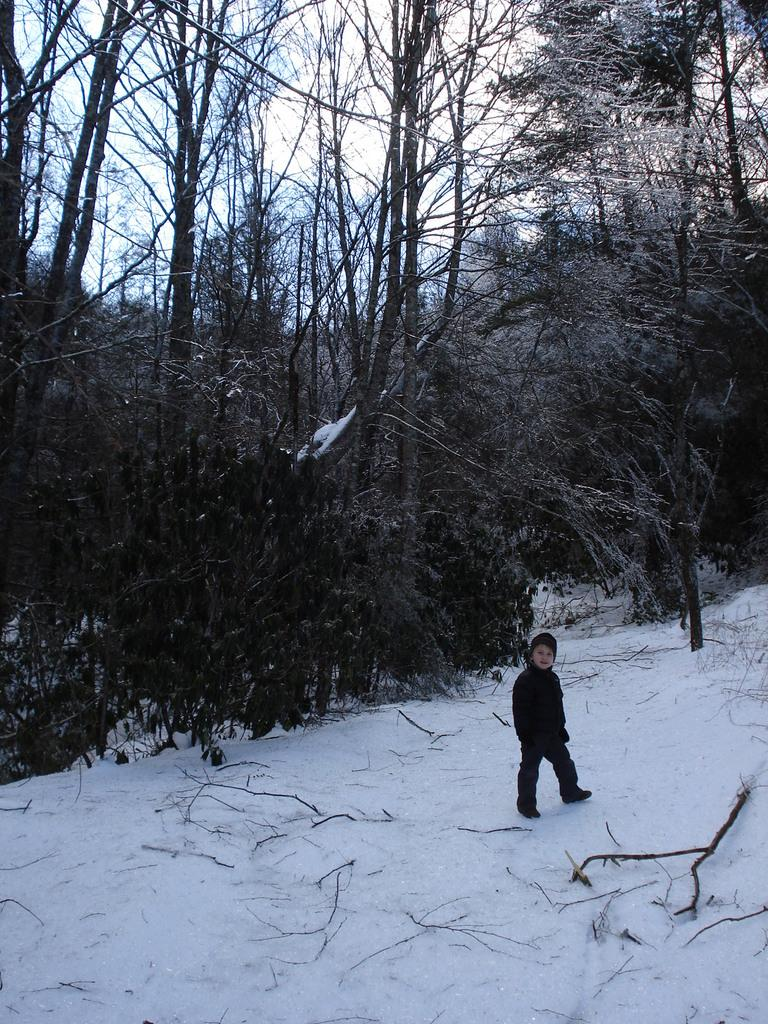What is the child doing in the image? The child is standing on the snow in the image. What else can be seen on the snow in the image? There are twigs on the snow in the image. What type of natural environment is depicted in the image? There are trees in the image, indicating a forest or wooded area. What is visible in the background of the image? The sky is visible in the image. What type of stove is being used by the child's grandfather in the image? There is no stove or grandfather present in the image. What items are on the child's list in the image? There is no list present in the image. 